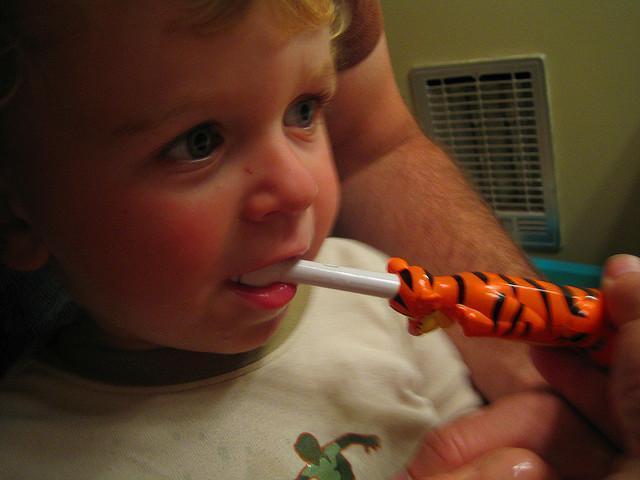How many toothbrushes does the boy have?
Give a very brief answer. 1. How many people can be seen?
Give a very brief answer. 2. 